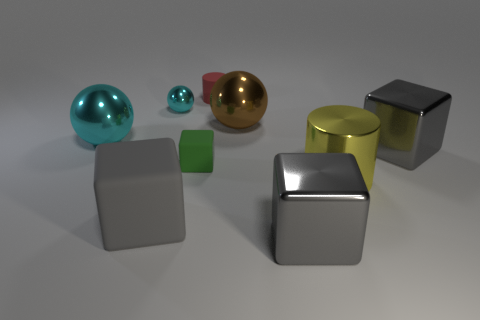How many gray cubes must be subtracted to get 1 gray cubes? 2 Subtract all green rubber cubes. How many cubes are left? 3 Subtract all cylinders. How many objects are left? 7 Subtract all yellow cylinders. How many gray cubes are left? 3 Add 9 large cyan objects. How many large cyan objects exist? 10 Subtract all cyan spheres. How many spheres are left? 1 Subtract 0 yellow balls. How many objects are left? 9 Subtract 1 cylinders. How many cylinders are left? 1 Subtract all red cylinders. Subtract all purple blocks. How many cylinders are left? 1 Subtract all cyan matte spheres. Subtract all big cyan balls. How many objects are left? 8 